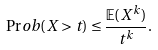Convert formula to latex. <formula><loc_0><loc_0><loc_500><loc_500>\Pr o b ( X > t ) \leq \frac { \mathbb { E } ( X ^ { k } ) } { t ^ { k } } .</formula> 